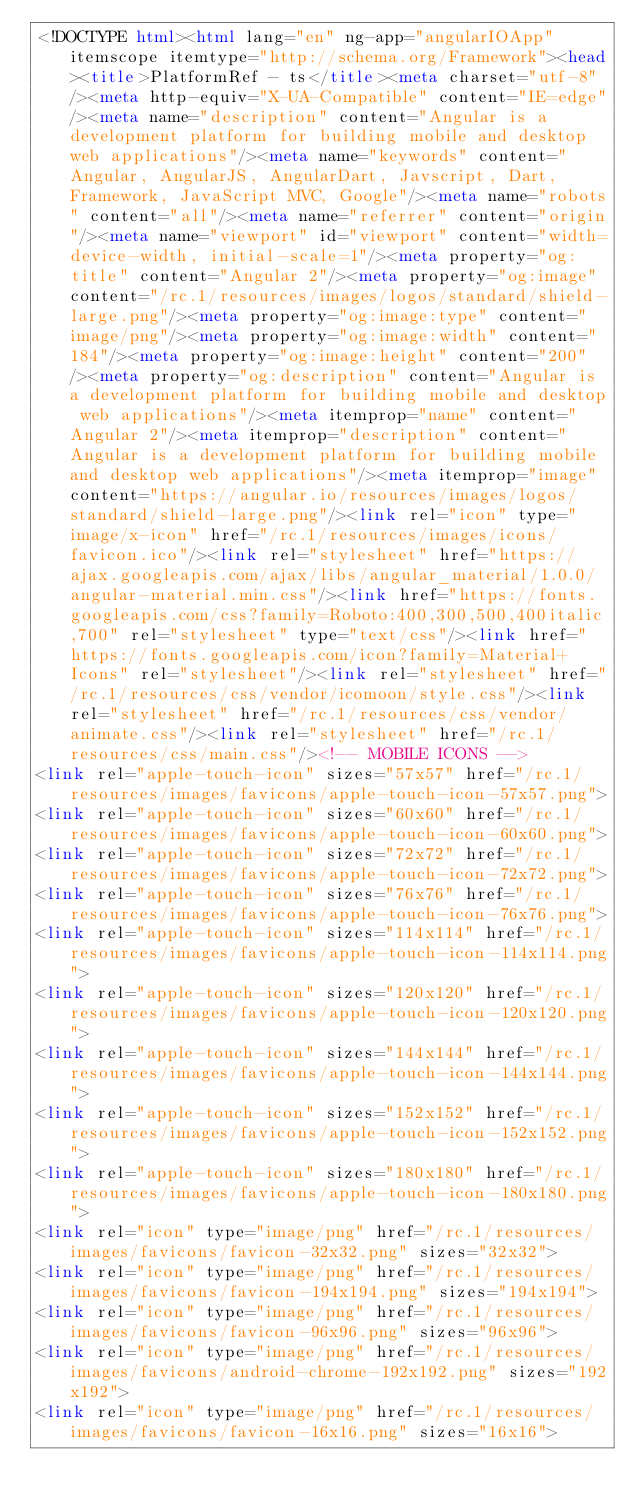<code> <loc_0><loc_0><loc_500><loc_500><_HTML_><!DOCTYPE html><html lang="en" ng-app="angularIOApp" itemscope itemtype="http://schema.org/Framework"><head><title>PlatformRef - ts</title><meta charset="utf-8"/><meta http-equiv="X-UA-Compatible" content="IE=edge"/><meta name="description" content="Angular is a development platform for building mobile and desktop web applications"/><meta name="keywords" content="Angular, AngularJS, AngularDart, Javscript, Dart, Framework, JavaScript MVC, Google"/><meta name="robots" content="all"/><meta name="referrer" content="origin"/><meta name="viewport" id="viewport" content="width=device-width, initial-scale=1"/><meta property="og:title" content="Angular 2"/><meta property="og:image" content="/rc.1/resources/images/logos/standard/shield-large.png"/><meta property="og:image:type" content="image/png"/><meta property="og:image:width" content="184"/><meta property="og:image:height" content="200"/><meta property="og:description" content="Angular is a development platform for building mobile and desktop web applications"/><meta itemprop="name" content="Angular 2"/><meta itemprop="description" content="Angular is a development platform for building mobile and desktop web applications"/><meta itemprop="image" content="https://angular.io/resources/images/logos/standard/shield-large.png"/><link rel="icon" type="image/x-icon" href="/rc.1/resources/images/icons/favicon.ico"/><link rel="stylesheet" href="https://ajax.googleapis.com/ajax/libs/angular_material/1.0.0/angular-material.min.css"/><link href="https://fonts.googleapis.com/css?family=Roboto:400,300,500,400italic,700" rel="stylesheet" type="text/css"/><link href="https://fonts.googleapis.com/icon?family=Material+Icons" rel="stylesheet"/><link rel="stylesheet" href="/rc.1/resources/css/vendor/icomoon/style.css"/><link rel="stylesheet" href="/rc.1/resources/css/vendor/animate.css"/><link rel="stylesheet" href="/rc.1/resources/css/main.css"/><!-- MOBILE ICONS -->
<link rel="apple-touch-icon" sizes="57x57" href="/rc.1/resources/images/favicons/apple-touch-icon-57x57.png">
<link rel="apple-touch-icon" sizes="60x60" href="/rc.1/resources/images/favicons/apple-touch-icon-60x60.png">
<link rel="apple-touch-icon" sizes="72x72" href="/rc.1/resources/images/favicons/apple-touch-icon-72x72.png">
<link rel="apple-touch-icon" sizes="76x76" href="/rc.1/resources/images/favicons/apple-touch-icon-76x76.png">
<link rel="apple-touch-icon" sizes="114x114" href="/rc.1/resources/images/favicons/apple-touch-icon-114x114.png">
<link rel="apple-touch-icon" sizes="120x120" href="/rc.1/resources/images/favicons/apple-touch-icon-120x120.png">
<link rel="apple-touch-icon" sizes="144x144" href="/rc.1/resources/images/favicons/apple-touch-icon-144x144.png">
<link rel="apple-touch-icon" sizes="152x152" href="/rc.1/resources/images/favicons/apple-touch-icon-152x152.png">
<link rel="apple-touch-icon" sizes="180x180" href="/rc.1/resources/images/favicons/apple-touch-icon-180x180.png">
<link rel="icon" type="image/png" href="/rc.1/resources/images/favicons/favicon-32x32.png" sizes="32x32">
<link rel="icon" type="image/png" href="/rc.1/resources/images/favicons/favicon-194x194.png" sizes="194x194">
<link rel="icon" type="image/png" href="/rc.1/resources/images/favicons/favicon-96x96.png" sizes="96x96">
<link rel="icon" type="image/png" href="/rc.1/resources/images/favicons/android-chrome-192x192.png" sizes="192x192">
<link rel="icon" type="image/png" href="/rc.1/resources/images/favicons/favicon-16x16.png" sizes="16x16"></code> 